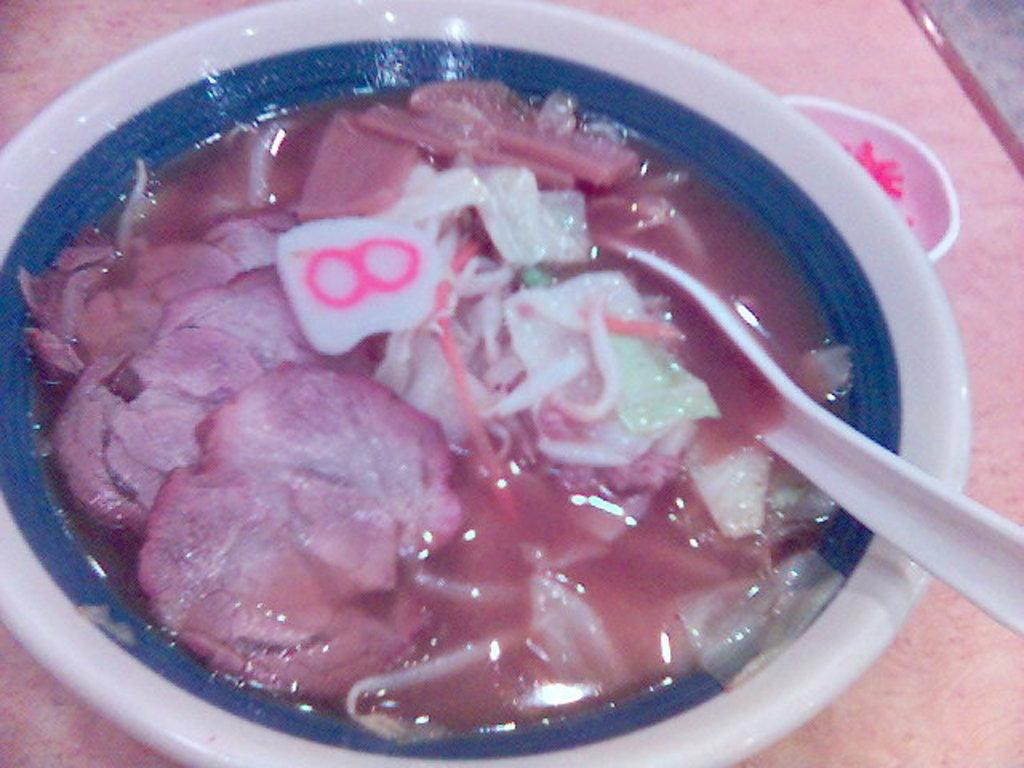What is in the bowl that is visible in the image? There is food in the bowl. What color is the bowl in the image? The bowl is white. What utensil is present in the bowl? There is a spoon in the bowl. What color is the spoon in the image? The spoon is white. How many rabbits are sitting on the books in the image? There are no rabbits or books present in the image. 